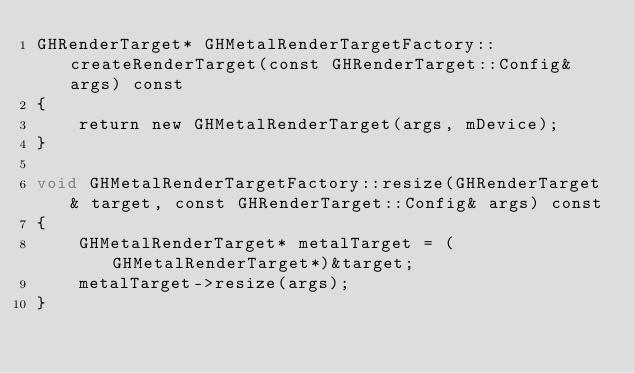Convert code to text. <code><loc_0><loc_0><loc_500><loc_500><_ObjectiveC_>GHRenderTarget* GHMetalRenderTargetFactory::createRenderTarget(const GHRenderTarget::Config& args) const
{
    return new GHMetalRenderTarget(args, mDevice);
}

void GHMetalRenderTargetFactory::resize(GHRenderTarget& target, const GHRenderTarget::Config& args) const
{
    GHMetalRenderTarget* metalTarget = (GHMetalRenderTarget*)&target;
    metalTarget->resize(args);
}
</code> 